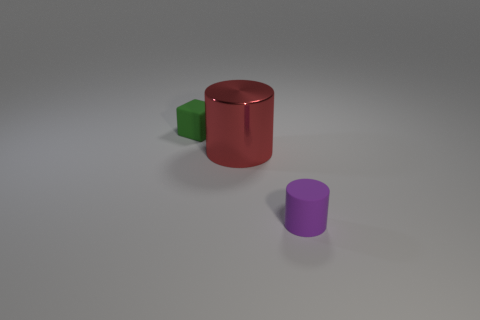Subtract 1 cubes. How many cubes are left? 0 Subtract all green cylinders. Subtract all green cubes. How many cylinders are left? 2 Subtract all yellow balls. How many red cylinders are left? 1 Subtract all big brown matte cubes. Subtract all tiny green rubber cubes. How many objects are left? 2 Add 3 rubber cylinders. How many rubber cylinders are left? 4 Add 2 tiny brown rubber balls. How many tiny brown rubber balls exist? 2 Add 1 large blue cubes. How many objects exist? 4 Subtract 0 cyan cubes. How many objects are left? 3 Subtract all blocks. How many objects are left? 2 